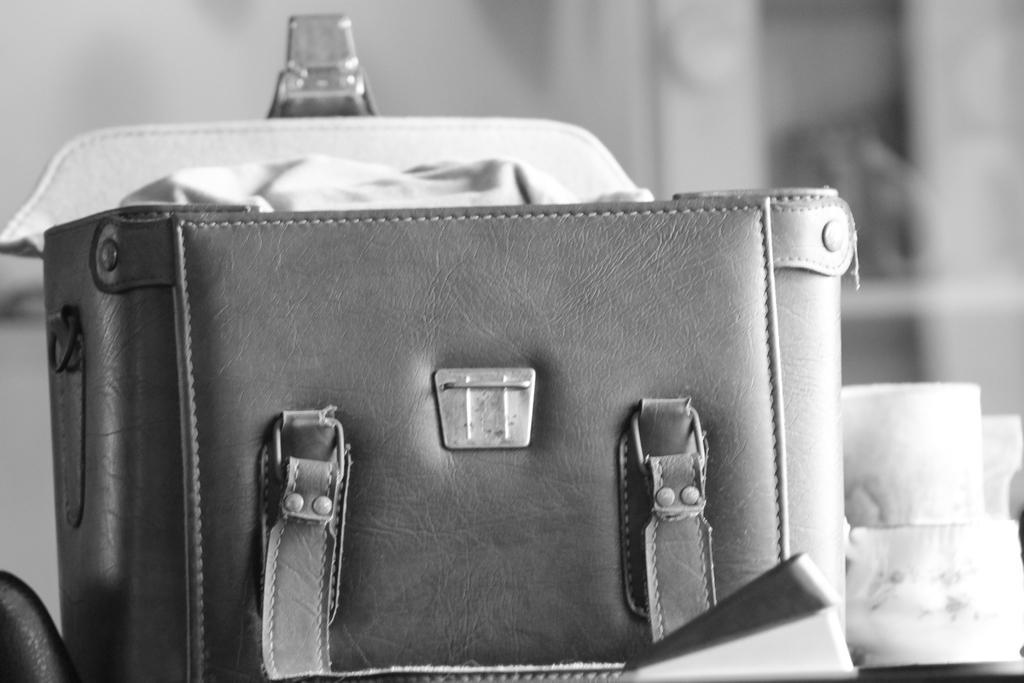Describe this image in one or two sentences. There is a bag. Beside the bag some object is their. And the bag is opened. 